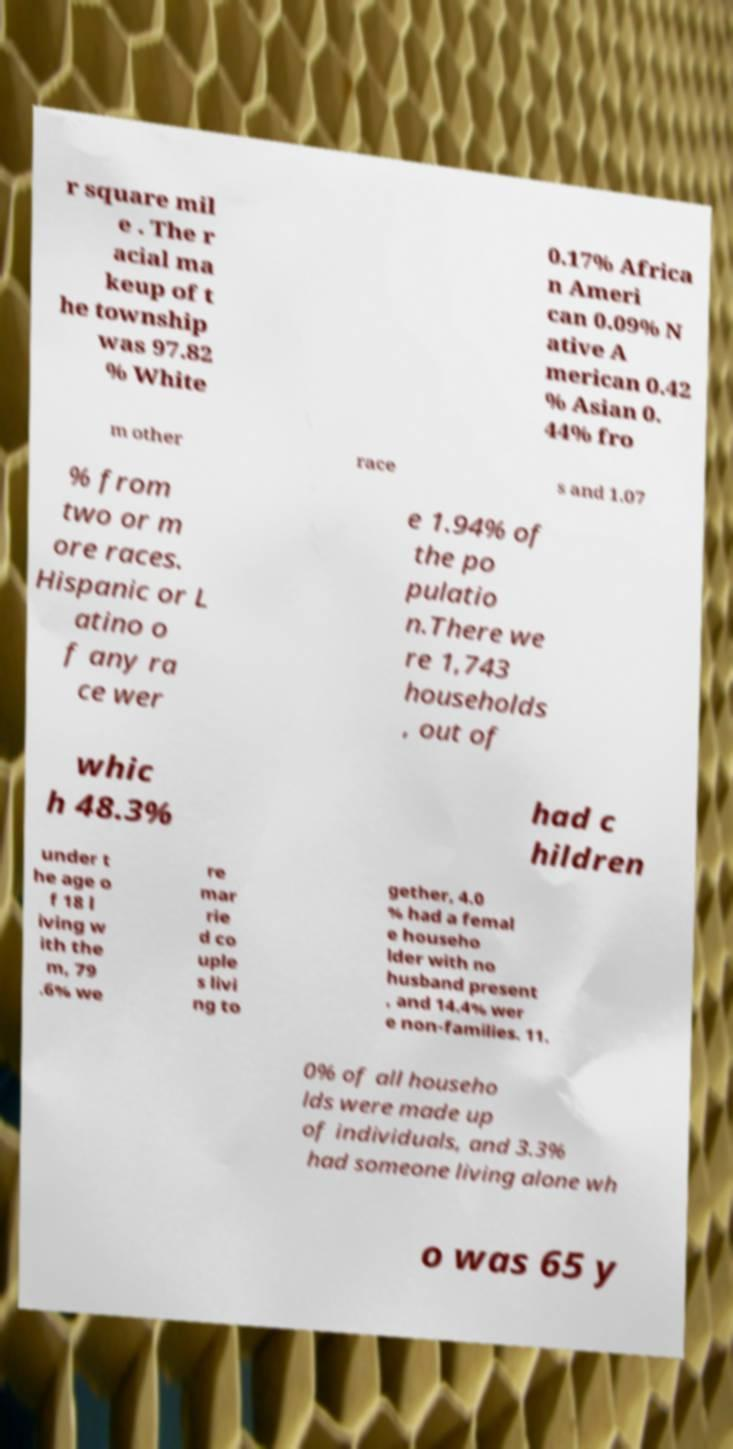Please identify and transcribe the text found in this image. r square mil e . The r acial ma keup of t he township was 97.82 % White 0.17% Africa n Ameri can 0.09% N ative A merican 0.42 % Asian 0. 44% fro m other race s and 1.07 % from two or m ore races. Hispanic or L atino o f any ra ce wer e 1.94% of the po pulatio n.There we re 1,743 households , out of whic h 48.3% had c hildren under t he age o f 18 l iving w ith the m, 79 .6% we re mar rie d co uple s livi ng to gether, 4.0 % had a femal e househo lder with no husband present , and 14.4% wer e non-families. 11. 0% of all househo lds were made up of individuals, and 3.3% had someone living alone wh o was 65 y 